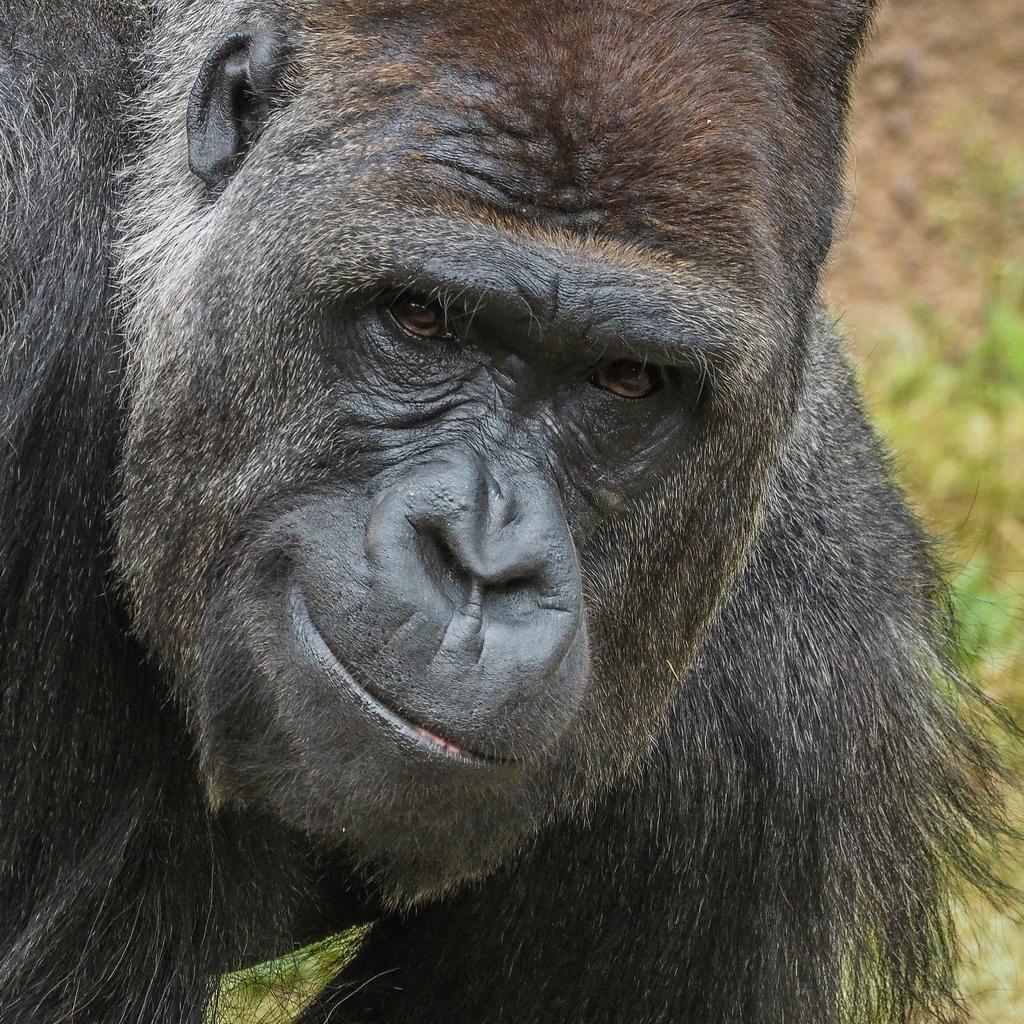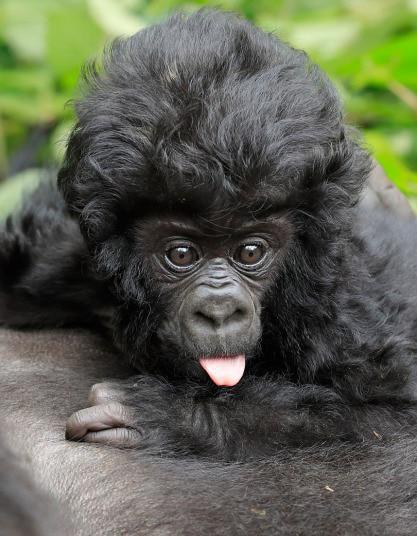The first image is the image on the left, the second image is the image on the right. Analyze the images presented: Is the assertion "The right image includes a fluffy baby gorilla with its tongue visible." valid? Answer yes or no. Yes. The first image is the image on the left, the second image is the image on the right. Evaluate the accuracy of this statement regarding the images: "There is a large gorilla in one image and at least a baby gorilla in the other image.". Is it true? Answer yes or no. Yes. 